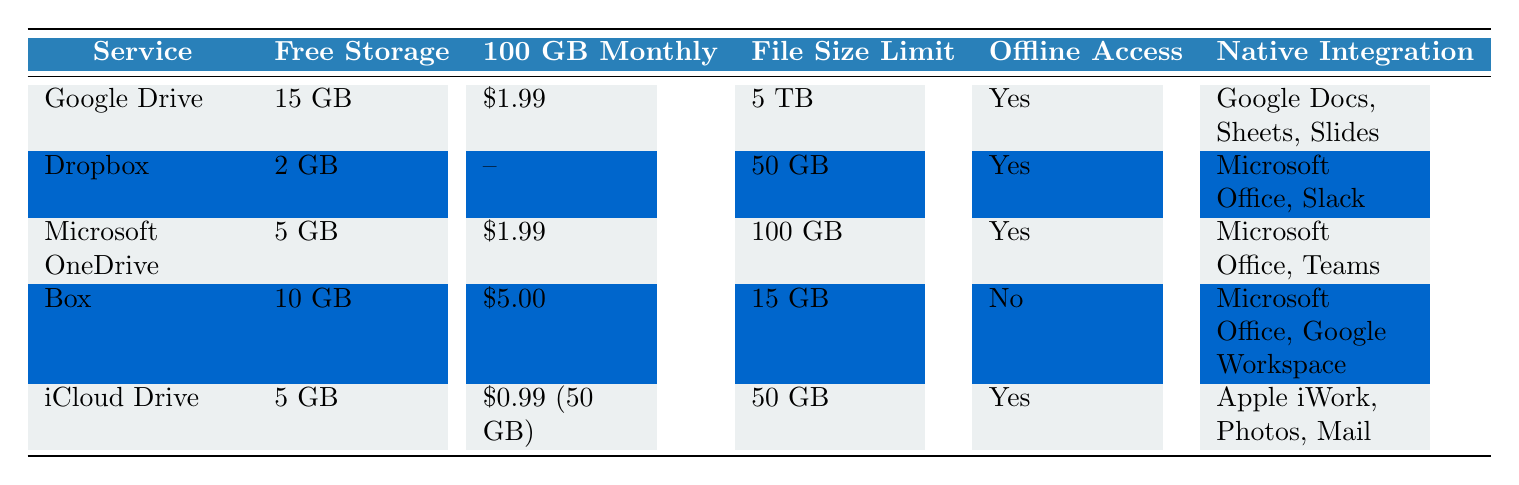What is the free storage capacity of Dropbox? The table shows that Dropbox has a free storage capacity of 2 GB.
Answer: 2 GB Which service offers the largest file size limit? The table indicates that Google Drive offers the largest file size limit of 5 TB compared to other services.
Answer: 5 TB Is offline access available for Box? According to the table, Box does not provide offline access since it states "No" under the offline access column.
Answer: No How many services have a free storage capacity of 5 GB? The table lists Microsoft OneDrive and iCloud Drive, both offering 5 GB of free storage, making a total of two services.
Answer: 2 What is the total monthly cost for obtaining 2 TB of storage in both Google Drive and Dropbox? For Google Drive, the cost for 2 TB is $9.99. For Dropbox, the cost for 2 TB is also $9.99. Therefore, the total cost is $9.99 + $9.99 = $19.98.
Answer: $19.98 Which services support collaboration features? The table shows that all listed services (Google Drive, Dropbox, Microsoft OneDrive, Box, and iCloud Drive) have true under the collaboration features column.
Answer: Yes What is the average free storage capacity of the services compared? The free storage capacities listed in the table are 15 GB (Google Drive), 2 GB (Dropbox), 5 GB (OneDrive), 10 GB (Box), and 5 GB (iCloud Drive). Adding these together, we have 15 + 2 + 5 + 10 + 5 = 37 GB. There are 5 services, so the average is 37/5 = 7.4 GB.
Answer: 7.4 GB Which service has the highest monthly cost for 100 GB storage? The table indicates that Box charges $5.00 for 100 GB, which is the highest among the services compared.
Answer: $5.00 Do all services offer two-factor authentication as a security feature? The table shows that all services except for Box offer two-factor authentication as a security feature, so the answer is false.
Answer: No 